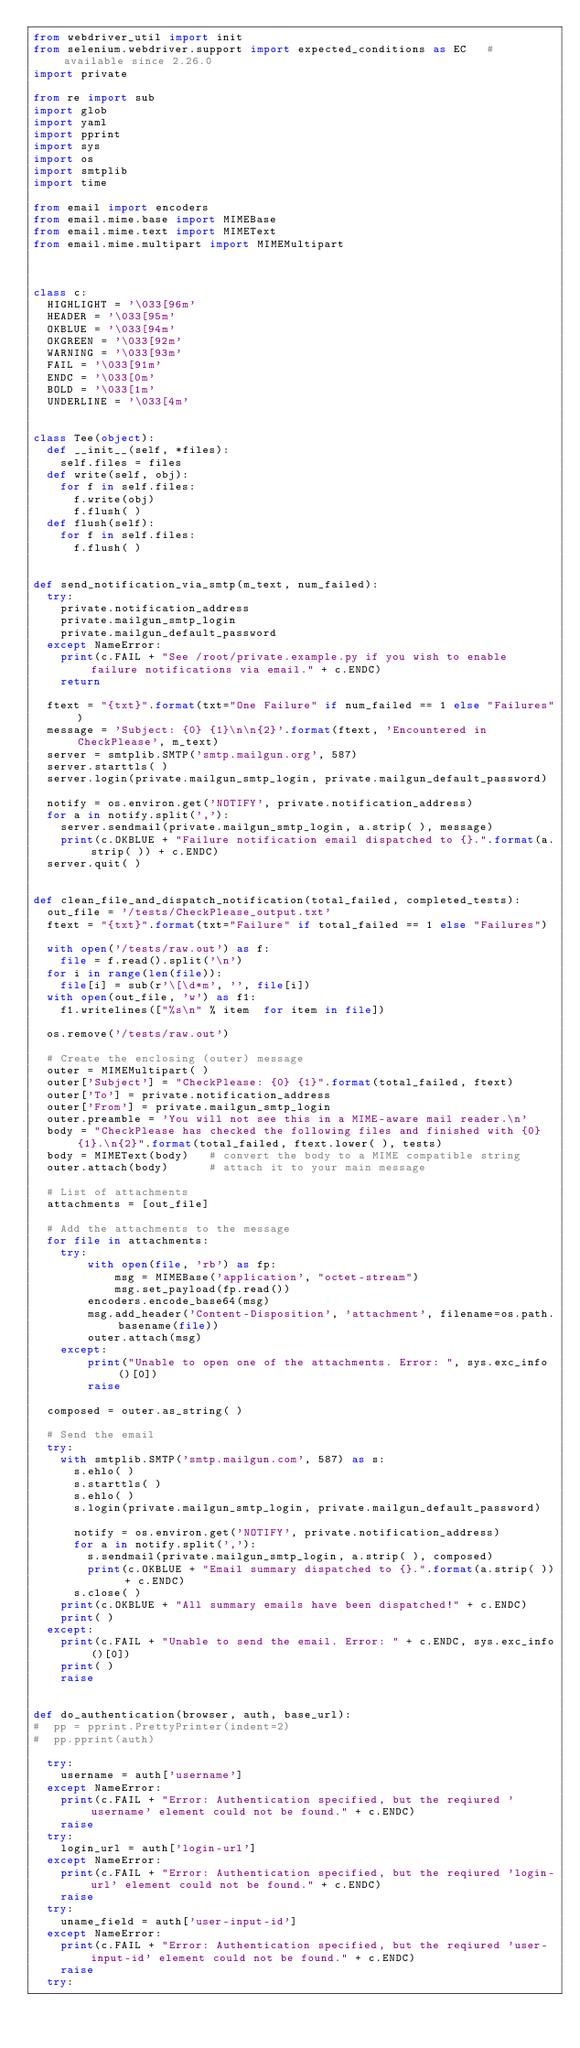Convert code to text. <code><loc_0><loc_0><loc_500><loc_500><_Python_>from webdriver_util import init
from selenium.webdriver.support import expected_conditions as EC   # available since 2.26.0
import private

from re import sub
import glob
import yaml
import pprint
import sys
import os
import smtplib
import time

from email import encoders
from email.mime.base import MIMEBase
from email.mime.text import MIMEText
from email.mime.multipart import MIMEMultipart



class c:
  HIGHLIGHT = '\033[96m'
  HEADER = '\033[95m'
  OKBLUE = '\033[94m'
  OKGREEN = '\033[92m'
  WARNING = '\033[93m'
  FAIL = '\033[91m'
  ENDC = '\033[0m'
  BOLD = '\033[1m'
  UNDERLINE = '\033[4m'


class Tee(object):
  def __init__(self, *files):
    self.files = files
  def write(self, obj):
    for f in self.files:
      f.write(obj)
      f.flush( )
  def flush(self):
    for f in self.files:
      f.flush( )


def send_notification_via_smtp(m_text, num_failed):
  try:
    private.notification_address
    private.mailgun_smtp_login
    private.mailgun_default_password
  except NameError:
    print(c.FAIL + "See /root/private.example.py if you wish to enable failure notifications via email." + c.ENDC)
    return

  ftext = "{txt}".format(txt="One Failure" if num_failed == 1 else "Failures")
  message = 'Subject: {0} {1}\n\n{2}'.format(ftext, 'Encountered in CheckPlease', m_text)
  server = smtplib.SMTP('smtp.mailgun.org', 587)
  server.starttls( )
  server.login(private.mailgun_smtp_login, private.mailgun_default_password)

  notify = os.environ.get('NOTIFY', private.notification_address)
  for a in notify.split(','):
    server.sendmail(private.mailgun_smtp_login, a.strip( ), message)
    print(c.OKBLUE + "Failure notification email dispatched to {}.".format(a.strip( )) + c.ENDC)
  server.quit( )


def clean_file_and_dispatch_notification(total_failed, completed_tests):
  out_file = '/tests/CheckPlease_output.txt'
  ftext = "{txt}".format(txt="Failure" if total_failed == 1 else "Failures")

  with open('/tests/raw.out') as f:
    file = f.read().split('\n')
  for i in range(len(file)):
    file[i] = sub(r'\[\d*m', '', file[i])
  with open(out_file, 'w') as f1:
    f1.writelines(["%s\n" % item  for item in file])

  os.remove('/tests/raw.out')

  # Create the enclosing (outer) message
  outer = MIMEMultipart( )
  outer['Subject'] = "CheckPlease: {0} {1}".format(total_failed, ftext)
  outer['To'] = private.notification_address
  outer['From'] = private.mailgun_smtp_login
  outer.preamble = 'You will not see this in a MIME-aware mail reader.\n'
  body = "CheckPlease has checked the following files and finished with {0} {1}.\n{2}".format(total_failed, ftext.lower( ), tests)
  body = MIMEText(body)   # convert the body to a MIME compatible string
  outer.attach(body)      # attach it to your main message

  # List of attachments
  attachments = [out_file]

  # Add the attachments to the message
  for file in attachments:
    try:
        with open(file, 'rb') as fp:
            msg = MIMEBase('application', "octet-stream")
            msg.set_payload(fp.read())
        encoders.encode_base64(msg)
        msg.add_header('Content-Disposition', 'attachment', filename=os.path.basename(file))
        outer.attach(msg)
    except:
        print("Unable to open one of the attachments. Error: ", sys.exc_info()[0])
        raise

  composed = outer.as_string( )

  # Send the email
  try:
    with smtplib.SMTP('smtp.mailgun.com', 587) as s:
      s.ehlo( )
      s.starttls( )
      s.ehlo( )
      s.login(private.mailgun_smtp_login, private.mailgun_default_password)

      notify = os.environ.get('NOTIFY', private.notification_address)
      for a in notify.split(','):
        s.sendmail(private.mailgun_smtp_login, a.strip( ), composed)
        print(c.OKBLUE + "Email summary dispatched to {}.".format(a.strip( )) + c.ENDC)
      s.close( )
    print(c.OKBLUE + "All summary emails have been dispatched!" + c.ENDC)
    print( )
  except:
    print(c.FAIL + "Unable to send the email. Error: " + c.ENDC, sys.exc_info()[0])
    print( )
    raise


def do_authentication(browser, auth, base_url):
#  pp = pprint.PrettyPrinter(indent=2)
#  pp.pprint(auth)

  try:
    username = auth['username']
  except NameError:
    print(c.FAIL + "Error: Authentication specified, but the reqiured 'username' element could not be found." + c.ENDC)
    raise
  try:
    login_url = auth['login-url']
  except NameError:
    print(c.FAIL + "Error: Authentication specified, but the reqiured 'login-url' element could not be found." + c.ENDC)
    raise
  try:
    uname_field = auth['user-input-id']
  except NameError:
    print(c.FAIL + "Error: Authentication specified, but the reqiured 'user-input-id' element could not be found." + c.ENDC)
    raise
  try:</code> 